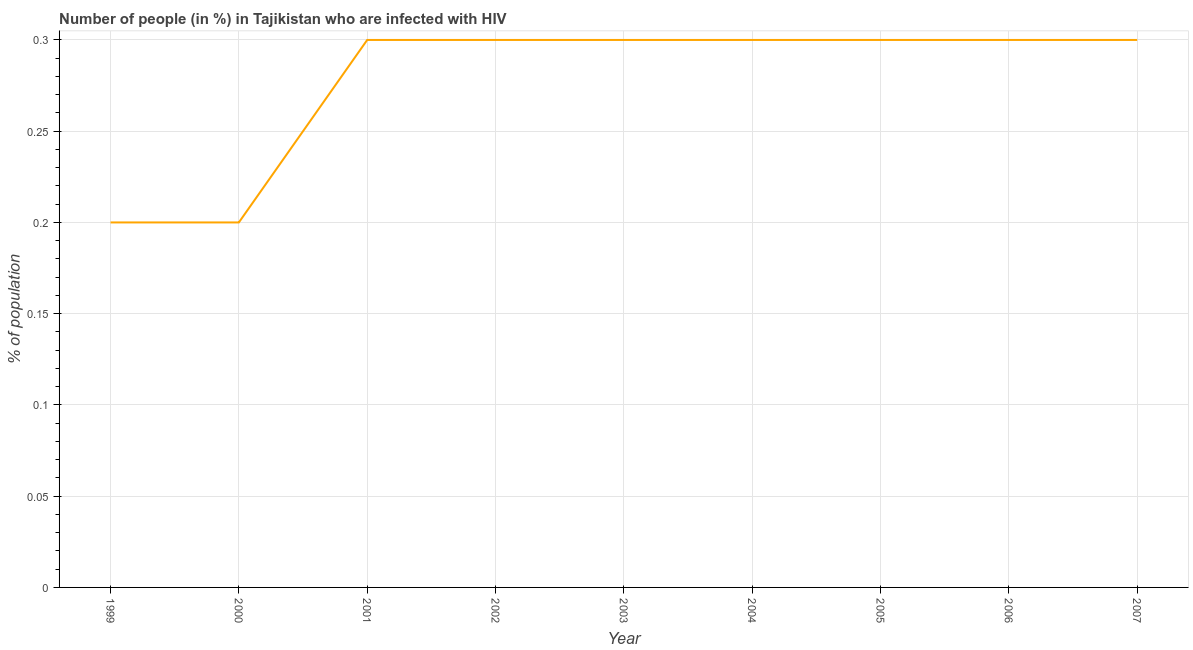What is the number of people infected with hiv in 1999?
Your answer should be very brief. 0.2. Across all years, what is the minimum number of people infected with hiv?
Keep it short and to the point. 0.2. In which year was the number of people infected with hiv maximum?
Your answer should be very brief. 2001. What is the average number of people infected with hiv per year?
Offer a terse response. 0.28. What is the median number of people infected with hiv?
Keep it short and to the point. 0.3. In how many years, is the number of people infected with hiv greater than 0.16000000000000003 %?
Provide a short and direct response. 9. Do a majority of the years between 2003 and 2005 (inclusive) have number of people infected with hiv greater than 0.13 %?
Ensure brevity in your answer.  Yes. Is the sum of the number of people infected with hiv in 2000 and 2005 greater than the maximum number of people infected with hiv across all years?
Your response must be concise. Yes. What is the difference between the highest and the lowest number of people infected with hiv?
Make the answer very short. 0.1. Does the number of people infected with hiv monotonically increase over the years?
Your response must be concise. No. How many lines are there?
Ensure brevity in your answer.  1. What is the difference between two consecutive major ticks on the Y-axis?
Your answer should be compact. 0.05. What is the title of the graph?
Your answer should be compact. Number of people (in %) in Tajikistan who are infected with HIV. What is the label or title of the Y-axis?
Make the answer very short. % of population. What is the % of population in 1999?
Provide a succinct answer. 0.2. What is the % of population of 2000?
Ensure brevity in your answer.  0.2. What is the % of population of 2002?
Provide a short and direct response. 0.3. What is the % of population in 2005?
Make the answer very short. 0.3. What is the % of population of 2006?
Your response must be concise. 0.3. What is the difference between the % of population in 1999 and 2000?
Your response must be concise. 0. What is the difference between the % of population in 1999 and 2002?
Offer a very short reply. -0.1. What is the difference between the % of population in 1999 and 2005?
Give a very brief answer. -0.1. What is the difference between the % of population in 1999 and 2006?
Give a very brief answer. -0.1. What is the difference between the % of population in 2000 and 2002?
Provide a short and direct response. -0.1. What is the difference between the % of population in 2000 and 2005?
Give a very brief answer. -0.1. What is the difference between the % of population in 2000 and 2006?
Ensure brevity in your answer.  -0.1. What is the difference between the % of population in 2001 and 2002?
Make the answer very short. 0. What is the difference between the % of population in 2001 and 2003?
Your answer should be compact. 0. What is the difference between the % of population in 2001 and 2004?
Provide a succinct answer. 0. What is the difference between the % of population in 2002 and 2003?
Give a very brief answer. 0. What is the difference between the % of population in 2002 and 2005?
Your response must be concise. 0. What is the difference between the % of population in 2002 and 2006?
Make the answer very short. 0. What is the difference between the % of population in 2002 and 2007?
Offer a very short reply. 0. What is the difference between the % of population in 2003 and 2004?
Your answer should be compact. 0. What is the difference between the % of population in 2003 and 2005?
Provide a short and direct response. 0. What is the difference between the % of population in 2003 and 2006?
Make the answer very short. 0. What is the difference between the % of population in 2004 and 2005?
Provide a succinct answer. 0. What is the difference between the % of population in 2005 and 2006?
Ensure brevity in your answer.  0. What is the difference between the % of population in 2006 and 2007?
Give a very brief answer. 0. What is the ratio of the % of population in 1999 to that in 2000?
Offer a very short reply. 1. What is the ratio of the % of population in 1999 to that in 2001?
Provide a succinct answer. 0.67. What is the ratio of the % of population in 1999 to that in 2002?
Your response must be concise. 0.67. What is the ratio of the % of population in 1999 to that in 2003?
Your response must be concise. 0.67. What is the ratio of the % of population in 1999 to that in 2004?
Your answer should be compact. 0.67. What is the ratio of the % of population in 1999 to that in 2005?
Offer a very short reply. 0.67. What is the ratio of the % of population in 1999 to that in 2006?
Keep it short and to the point. 0.67. What is the ratio of the % of population in 1999 to that in 2007?
Make the answer very short. 0.67. What is the ratio of the % of population in 2000 to that in 2001?
Ensure brevity in your answer.  0.67. What is the ratio of the % of population in 2000 to that in 2002?
Offer a terse response. 0.67. What is the ratio of the % of population in 2000 to that in 2003?
Give a very brief answer. 0.67. What is the ratio of the % of population in 2000 to that in 2004?
Provide a short and direct response. 0.67. What is the ratio of the % of population in 2000 to that in 2005?
Your answer should be very brief. 0.67. What is the ratio of the % of population in 2000 to that in 2006?
Ensure brevity in your answer.  0.67. What is the ratio of the % of population in 2000 to that in 2007?
Give a very brief answer. 0.67. What is the ratio of the % of population in 2001 to that in 2003?
Provide a succinct answer. 1. What is the ratio of the % of population in 2001 to that in 2004?
Your answer should be very brief. 1. What is the ratio of the % of population in 2001 to that in 2007?
Make the answer very short. 1. What is the ratio of the % of population in 2002 to that in 2003?
Provide a succinct answer. 1. What is the ratio of the % of population in 2002 to that in 2004?
Offer a terse response. 1. What is the ratio of the % of population in 2002 to that in 2007?
Provide a succinct answer. 1. What is the ratio of the % of population in 2003 to that in 2005?
Ensure brevity in your answer.  1. What is the ratio of the % of population in 2003 to that in 2007?
Give a very brief answer. 1. What is the ratio of the % of population in 2005 to that in 2006?
Make the answer very short. 1. What is the ratio of the % of population in 2005 to that in 2007?
Offer a terse response. 1. 